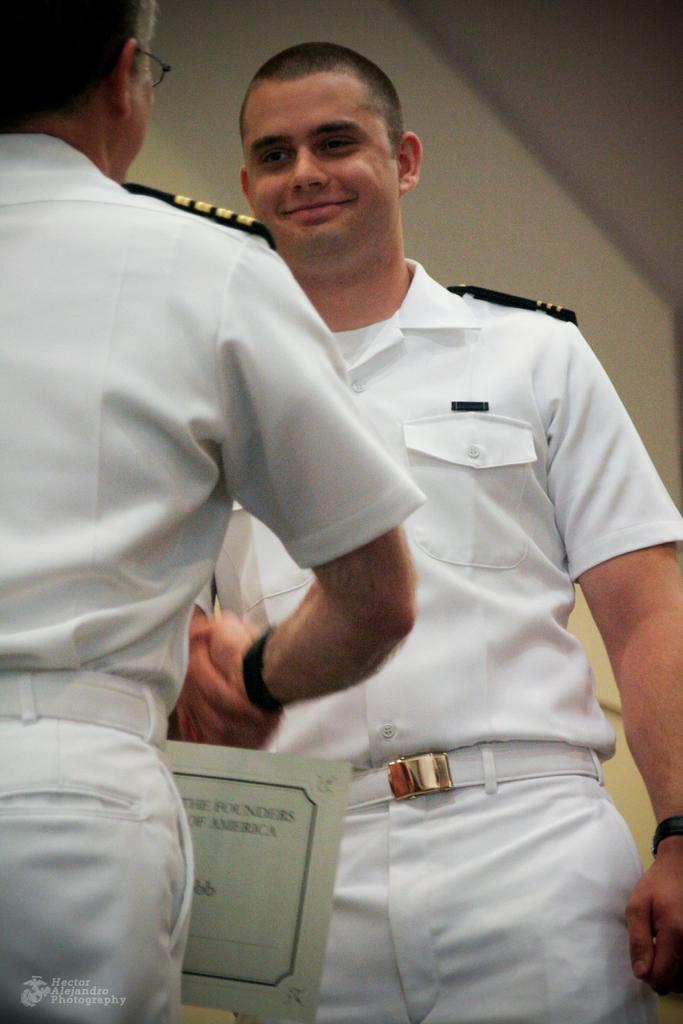Could you give a brief overview of what you see in this image? In this image we can see two people standing and shaking their hands. They are wearing uniforms. We can see a board. In the background there is a wall. 